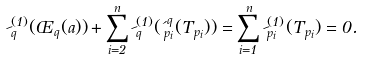<formula> <loc_0><loc_0><loc_500><loc_500>\psi _ { q } ^ { ( 1 ) } ( \phi _ { q } ( a ) ) + \sum _ { i = 2 } ^ { n } \psi _ { q } ^ { ( 1 ) } ( \iota _ { p _ { i } } ^ { q } ( T _ { p _ { i } } ) ) = \sum _ { i = 1 } ^ { n } \psi _ { p _ { i } } ^ { ( 1 ) } ( T _ { p _ { i } } ) = 0 .</formula> 